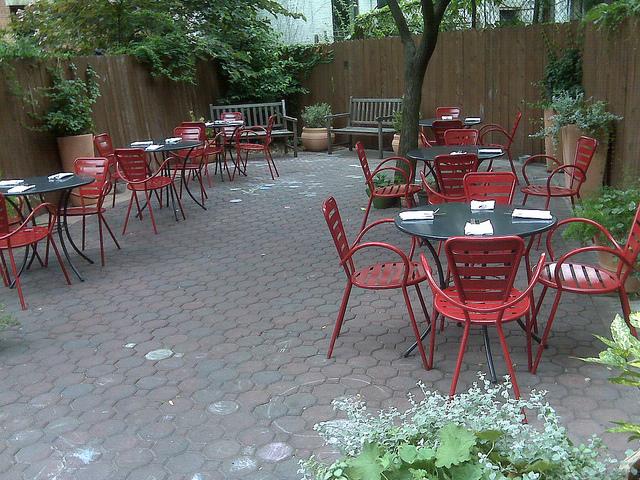How many red chairs?
Write a very short answer. 20. What type of activity goes on at the tables?
Answer briefly. Eating. How many tables are in the picture?
Write a very short answer. 6. 